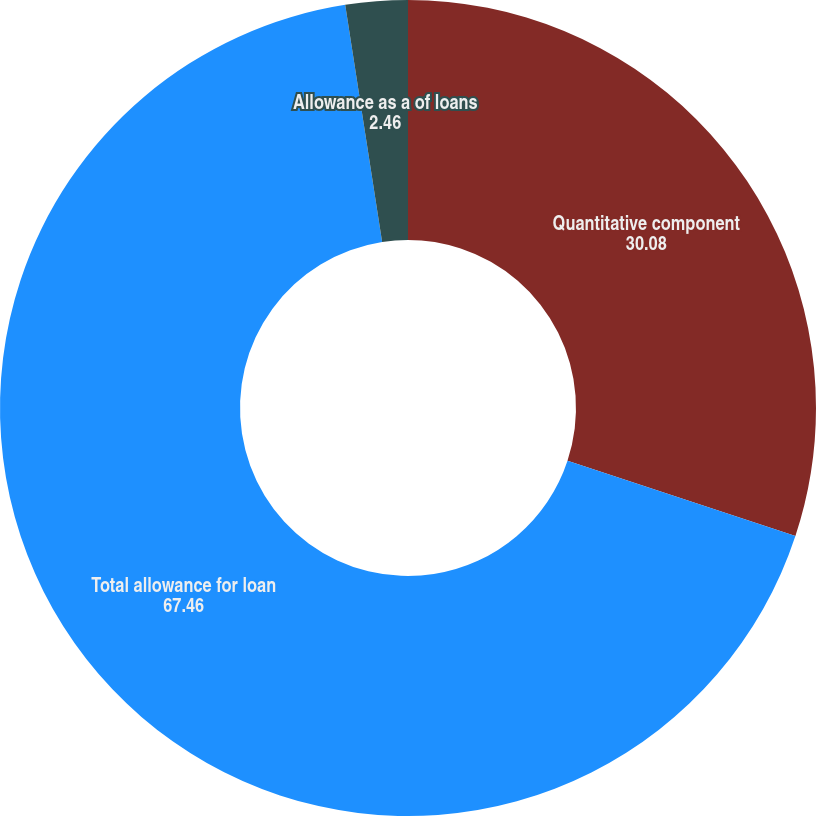<chart> <loc_0><loc_0><loc_500><loc_500><pie_chart><fcel>Quantitative component<fcel>Total allowance for loan<fcel>Allowance as a of loans<nl><fcel>30.08%<fcel>67.46%<fcel>2.46%<nl></chart> 